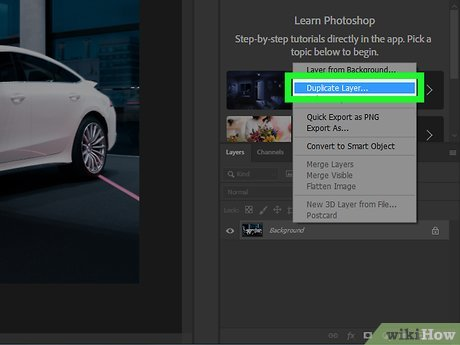You are doing Using a Double Loaded Paint Brush. Is the step "Double-load a brush with your main color and white." the next or previous step to the step in the image? The image shows a Photoshop interface and specifically a step involving 'Duplicate Layer,' which is a digital photo editing task used to manage and manipulate layers. This is distinct and unrelated to the traditional art technique of using a double-loaded paintbrush, which involves manually mixing two colors directly on the brush for application. Therefore, 'Double-load a brush with your main color and white' isn't a next or previous step relative to the digital editing process shown in the image but rather a separate, unrelated activity related to physical painting. 